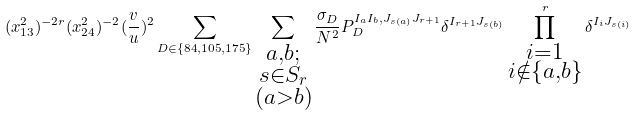Convert formula to latex. <formula><loc_0><loc_0><loc_500><loc_500>( x _ { 1 3 } ^ { 2 } ) ^ { - 2 r } ( x _ { 2 4 } ^ { 2 } ) ^ { - 2 } ( \frac { v } { u } ) ^ { 2 } \sum _ { D \in \{ { 8 4 } , { 1 0 5 } , { 1 7 5 } \} } \sum _ { \substack { a , b ; \\ s \in S _ { r } \\ ( a > b ) } } \frac { \sigma _ { D } } { N ^ { 2 } } P _ { D } ^ { I _ { a } I _ { b } , J _ { s ( a ) } J _ { r + 1 } } \delta ^ { I _ { r + 1 } J _ { s ( b ) } } \prod ^ { r } _ { \substack { i = 1 \\ i \notin \{ a , b \} } } \delta ^ { I _ { i } J _ { s ( i ) } }</formula> 